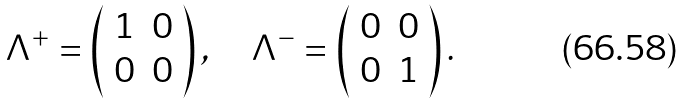Convert formula to latex. <formula><loc_0><loc_0><loc_500><loc_500>\Lambda ^ { + } = \left ( \begin{array} { r r } 1 & 0 \\ 0 & 0 \end{array} \right ) , \quad \Lambda ^ { - } = \left ( \begin{array} { r r } 0 & 0 \\ 0 & 1 \end{array} \right ) .</formula> 